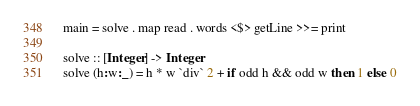<code> <loc_0><loc_0><loc_500><loc_500><_Haskell_>main = solve . map read . words <$> getLine >>= print

solve :: [Integer] -> Integer
solve (h:w:_) = h * w `div` 2 + if odd h && odd w then 1 else 0
</code> 